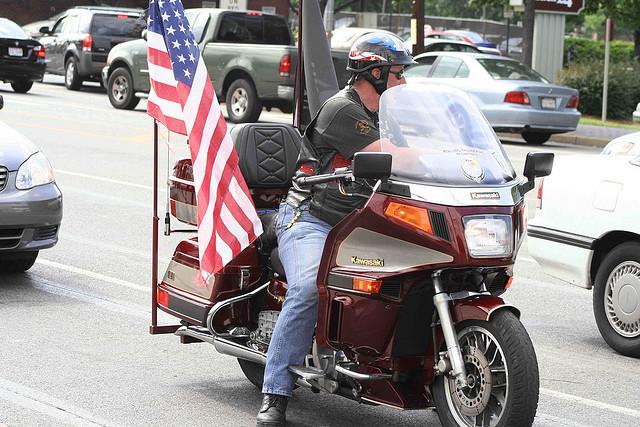How many people can sit on the bike?
Give a very brief answer. 2. Is this in the United Kingdom?
Short answer required. No. Is there a lot of traffic?
Be succinct. Yes. What is the street made from?
Concise answer only. Asphalt. Is this a police motorcycle?
Short answer required. No. Which country does the flag come from?
Write a very short answer. America. What color is the truck?
Answer briefly. Gray. What country's flag is on the back of the motorcycle?
Quick response, please. Usa. 